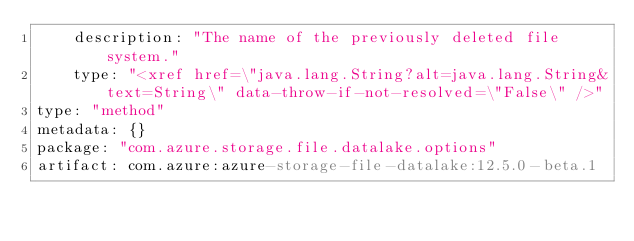Convert code to text. <code><loc_0><loc_0><loc_500><loc_500><_YAML_>    description: "The name of the previously deleted file system."
    type: "<xref href=\"java.lang.String?alt=java.lang.String&text=String\" data-throw-if-not-resolved=\"False\" />"
type: "method"
metadata: {}
package: "com.azure.storage.file.datalake.options"
artifact: com.azure:azure-storage-file-datalake:12.5.0-beta.1
</code> 